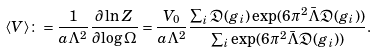<formula> <loc_0><loc_0><loc_500><loc_500>\langle V \rangle \colon = \frac { 1 } { a \Lambda ^ { 2 } } \frac { \partial \ln Z } { \partial \log \Omega } = \frac { V _ { 0 } } { a \Lambda ^ { 2 } } \frac { \sum _ { i } \mathfrak { D } ( g _ { i } ) \exp ( 6 \pi ^ { 2 } \bar { \Lambda } \mathfrak { D } ( g _ { i } ) ) } { \sum _ { i } \exp ( 6 \pi ^ { 2 } \bar { \Lambda } \mathfrak { D } ( g _ { i } ) ) } .</formula> 